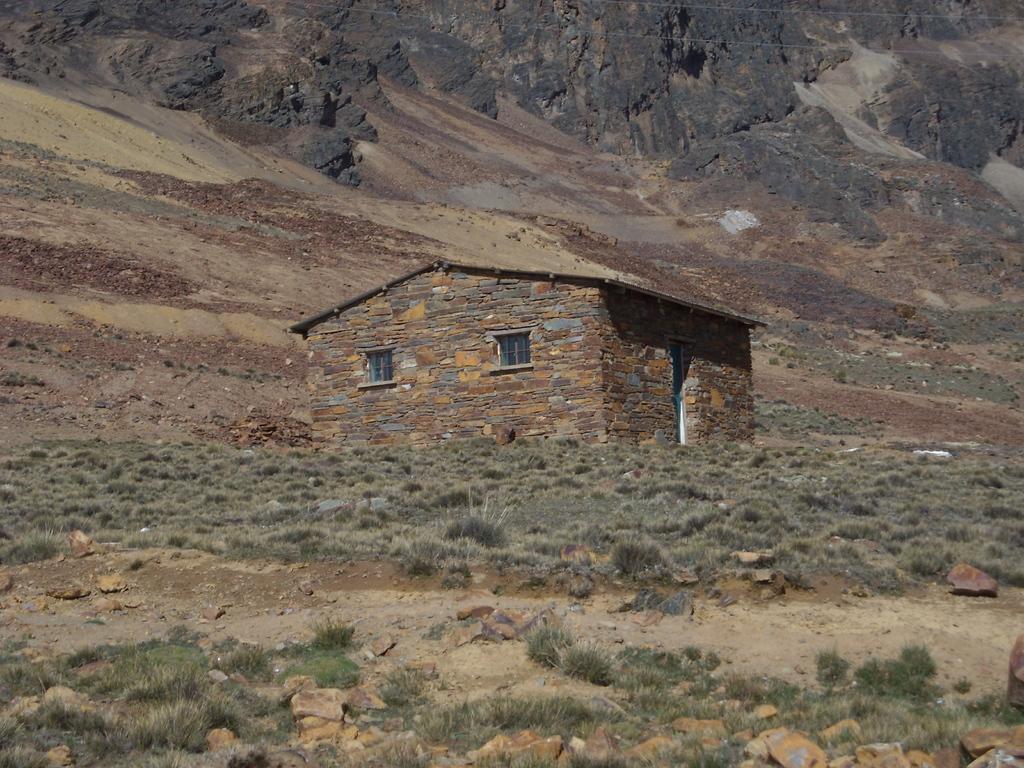How would you summarize this image in a sentence or two? In this picture we can see grass and a house on the ground and in the background we can see rocks. 